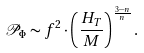<formula> <loc_0><loc_0><loc_500><loc_500>\mathcal { P } _ { \Phi } \sim f ^ { 2 } \cdot \left ( \frac { H _ { T } } { M } \right ) ^ { \frac { 3 - n } { n } } .</formula> 